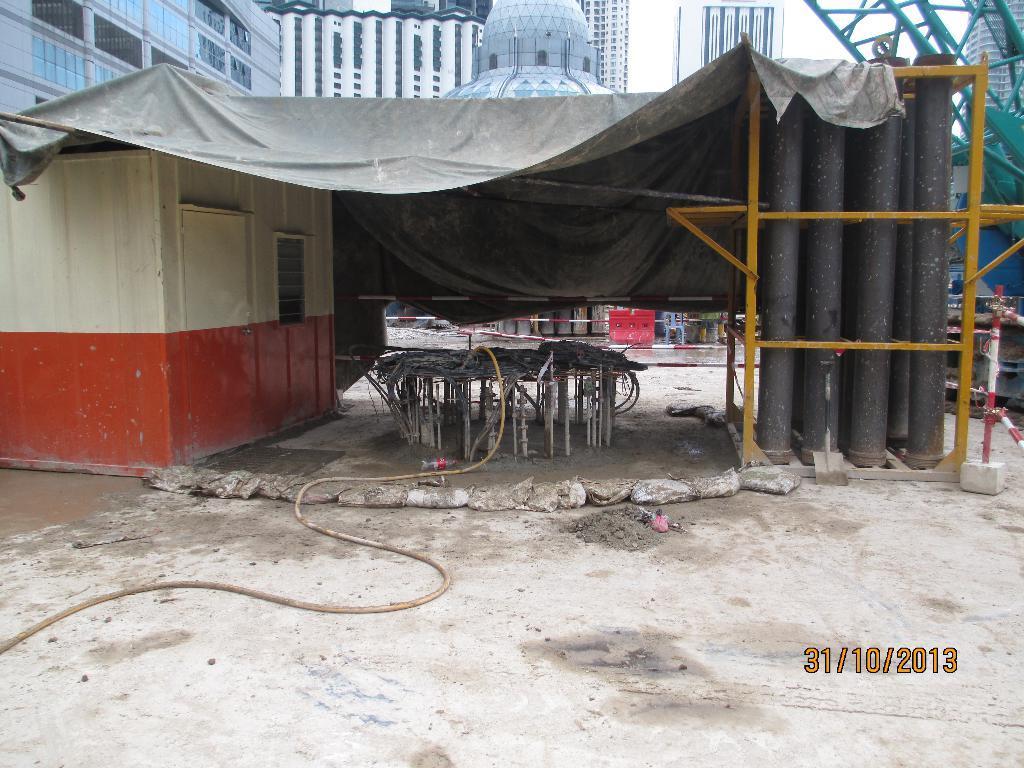Describe this image in one or two sentences. In this image I can see the ground, a pipe, few black colored huge pipes, few metal rods, a black colored sheet and a shed. In the background I can see few buildings, few metals rods and the sky. 